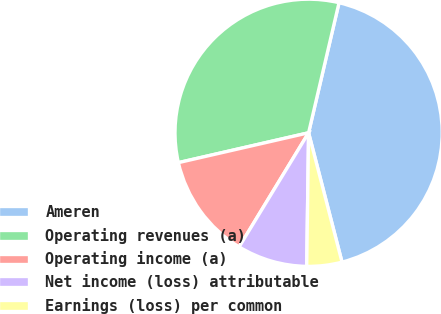Convert chart. <chart><loc_0><loc_0><loc_500><loc_500><pie_chart><fcel>Ameren<fcel>Operating revenues (a)<fcel>Operating income (a)<fcel>Net income (loss) attributable<fcel>Earnings (loss) per common<nl><fcel>42.32%<fcel>32.25%<fcel>12.71%<fcel>8.48%<fcel>4.25%<nl></chart> 